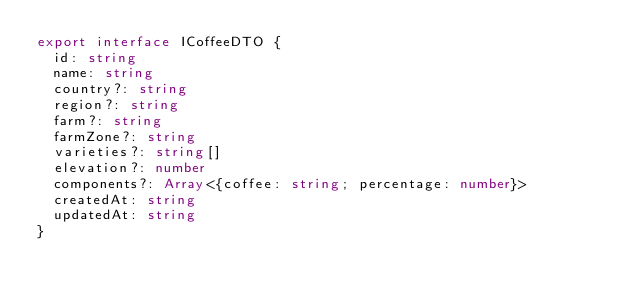<code> <loc_0><loc_0><loc_500><loc_500><_TypeScript_>export interface ICoffeeDTO {
  id: string
  name: string
  country?: string
  region?: string
  farm?: string
  farmZone?: string
  varieties?: string[]
  elevation?: number
  components?: Array<{coffee: string; percentage: number}>
  createdAt: string
  updatedAt: string
}
</code> 